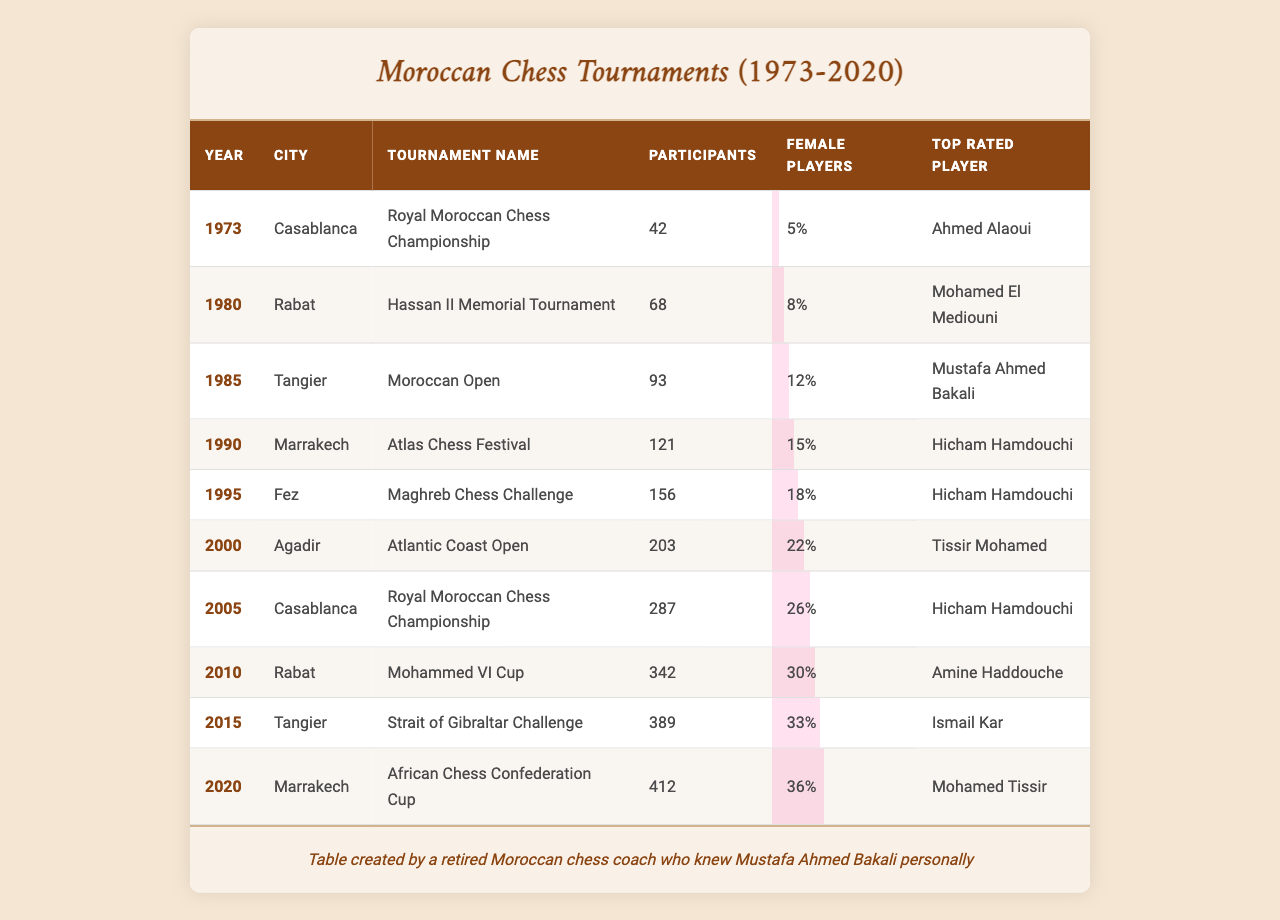What was the highest number of participants in a tournament and in which year did it occur? The highest number of participants in a tournament is 412, occurring in 2020 at the African Chess Confederation Cup in Marrakech.
Answer: 412, 2020 In which city was the "Hassan II Memorial Tournament" held? The "Hassan II Memorial Tournament" was held in Rabat.
Answer: Rabat What percentage of female players participated in the "Royal Moroccan Chess Championship" in 2005? In 2005, 26% of female players participated in the "Royal Moroccan Chess Championship."
Answer: 26% Which tournament had the highest percentage of female players? The tournament with the highest percentage of female players is the "African Chess Confederation Cup" in 2020 with 36%.
Answer: 36% How many tournaments had more than 300 participants? There are 4 tournaments with more than 300 participants: in 2005, 2010, 2015, and 2020.
Answer: 4 What is the average number of participants across all tournaments? The sum of participants is 2,470 and there are 10 tournaments, so the average is 2,470/10 = 247.
Answer: 247 In what year did "Mustafa Ahmed Bakali" achieve recognition as the top-rated player? "Mustafa Ahmed Bakali" was the top-rated player in 1985 during the Moroccan Open.
Answer: 1985 Did the percentage of female players increase in the tournaments over time? Yes, the percentage of female players increased from 5% in 1973 to 36% in 2020, indicating a trend of growth.
Answer: Yes How many participants were there in the "Maghreb Chess Challenge" in Fez? There were 156 participants in the "Maghreb Chess Challenge" in Fez in 1995.
Answer: 156 What was the percentage of female players in the "Strait of Gibraltar Challenge" held in Tangier in 2015? The percentage of female players in the "Strait of Gibraltar Challenge" in 2015 was 33%.
Answer: 33% 